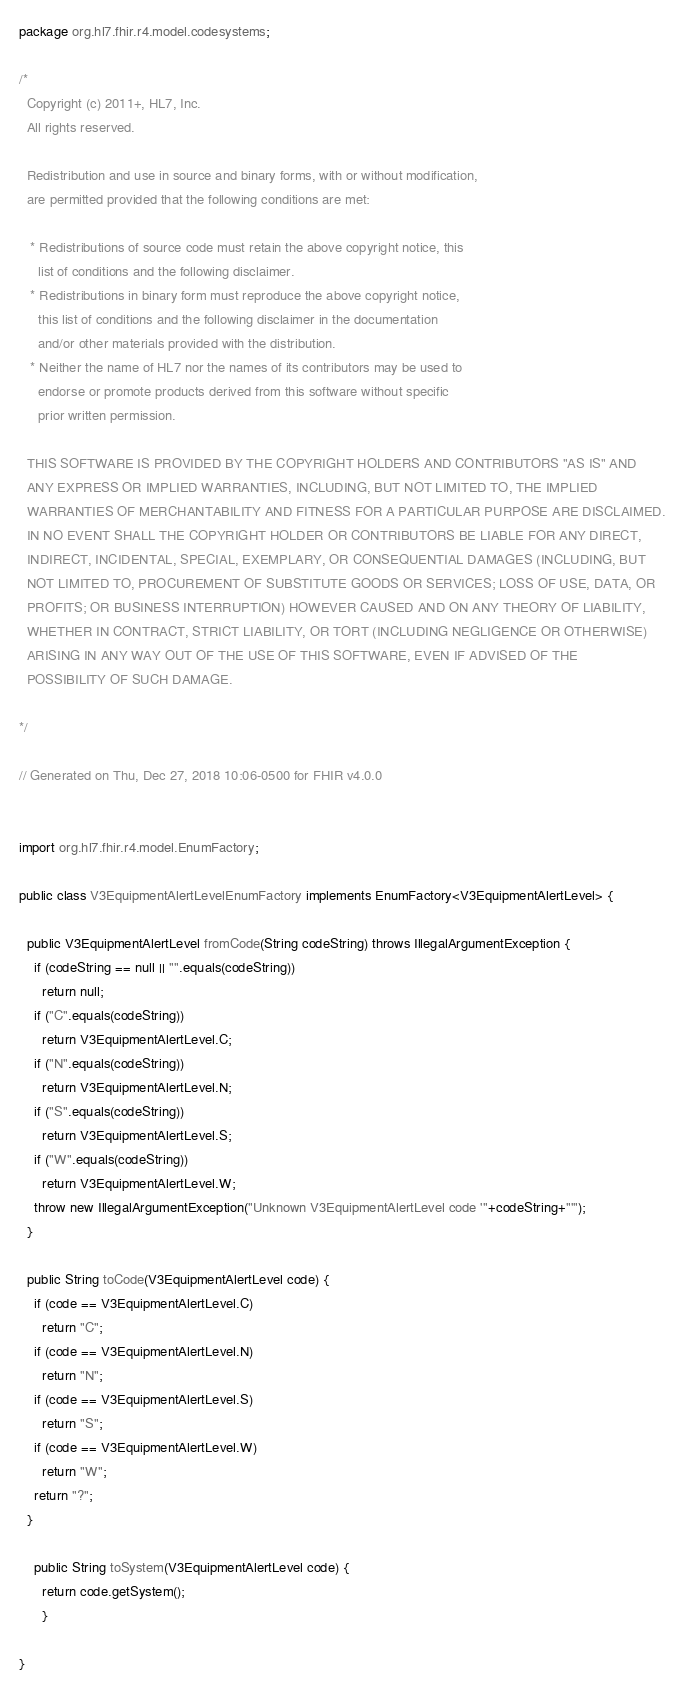Convert code to text. <code><loc_0><loc_0><loc_500><loc_500><_Java_>package org.hl7.fhir.r4.model.codesystems;

/*
  Copyright (c) 2011+, HL7, Inc.
  All rights reserved.
  
  Redistribution and use in source and binary forms, with or without modification, 
  are permitted provided that the following conditions are met:
  
   * Redistributions of source code must retain the above copyright notice, this 
     list of conditions and the following disclaimer.
   * Redistributions in binary form must reproduce the above copyright notice, 
     this list of conditions and the following disclaimer in the documentation 
     and/or other materials provided with the distribution.
   * Neither the name of HL7 nor the names of its contributors may be used to 
     endorse or promote products derived from this software without specific 
     prior written permission.
  
  THIS SOFTWARE IS PROVIDED BY THE COPYRIGHT HOLDERS AND CONTRIBUTORS "AS IS" AND 
  ANY EXPRESS OR IMPLIED WARRANTIES, INCLUDING, BUT NOT LIMITED TO, THE IMPLIED 
  WARRANTIES OF MERCHANTABILITY AND FITNESS FOR A PARTICULAR PURPOSE ARE DISCLAIMED. 
  IN NO EVENT SHALL THE COPYRIGHT HOLDER OR CONTRIBUTORS BE LIABLE FOR ANY DIRECT, 
  INDIRECT, INCIDENTAL, SPECIAL, EXEMPLARY, OR CONSEQUENTIAL DAMAGES (INCLUDING, BUT 
  NOT LIMITED TO, PROCUREMENT OF SUBSTITUTE GOODS OR SERVICES; LOSS OF USE, DATA, OR 
  PROFITS; OR BUSINESS INTERRUPTION) HOWEVER CAUSED AND ON ANY THEORY OF LIABILITY, 
  WHETHER IN CONTRACT, STRICT LIABILITY, OR TORT (INCLUDING NEGLIGENCE OR OTHERWISE) 
  ARISING IN ANY WAY OUT OF THE USE OF THIS SOFTWARE, EVEN IF ADVISED OF THE 
  POSSIBILITY OF SUCH DAMAGE.
  
*/

// Generated on Thu, Dec 27, 2018 10:06-0500 for FHIR v4.0.0


import org.hl7.fhir.r4.model.EnumFactory;

public class V3EquipmentAlertLevelEnumFactory implements EnumFactory<V3EquipmentAlertLevel> {

  public V3EquipmentAlertLevel fromCode(String codeString) throws IllegalArgumentException {
    if (codeString == null || "".equals(codeString))
      return null;
    if ("C".equals(codeString))
      return V3EquipmentAlertLevel.C;
    if ("N".equals(codeString))
      return V3EquipmentAlertLevel.N;
    if ("S".equals(codeString))
      return V3EquipmentAlertLevel.S;
    if ("W".equals(codeString))
      return V3EquipmentAlertLevel.W;
    throw new IllegalArgumentException("Unknown V3EquipmentAlertLevel code '"+codeString+"'");
  }

  public String toCode(V3EquipmentAlertLevel code) {
    if (code == V3EquipmentAlertLevel.C)
      return "C";
    if (code == V3EquipmentAlertLevel.N)
      return "N";
    if (code == V3EquipmentAlertLevel.S)
      return "S";
    if (code == V3EquipmentAlertLevel.W)
      return "W";
    return "?";
  }

    public String toSystem(V3EquipmentAlertLevel code) {
      return code.getSystem();
      }

}

</code> 